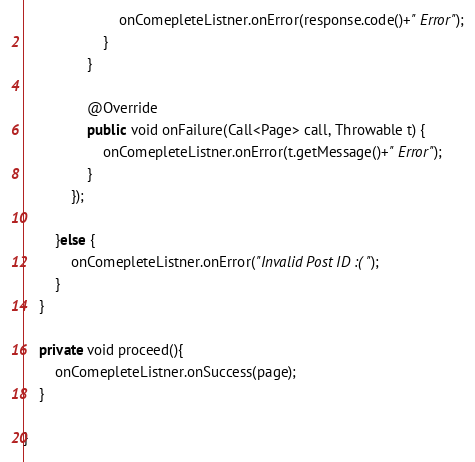Convert code to text. <code><loc_0><loc_0><loc_500><loc_500><_Java_>                        onComepleteListner.onError(response.code()+" Error");
                    }
                }

                @Override
                public void onFailure(Call<Page> call, Throwable t) {
                    onComepleteListner.onError(t.getMessage()+" Error");
                }
            });

        }else {
            onComepleteListner.onError("Invalid Post ID :(");
        }
    }

    private void proceed(){
        onComepleteListner.onSuccess(page);
    }

}
</code> 